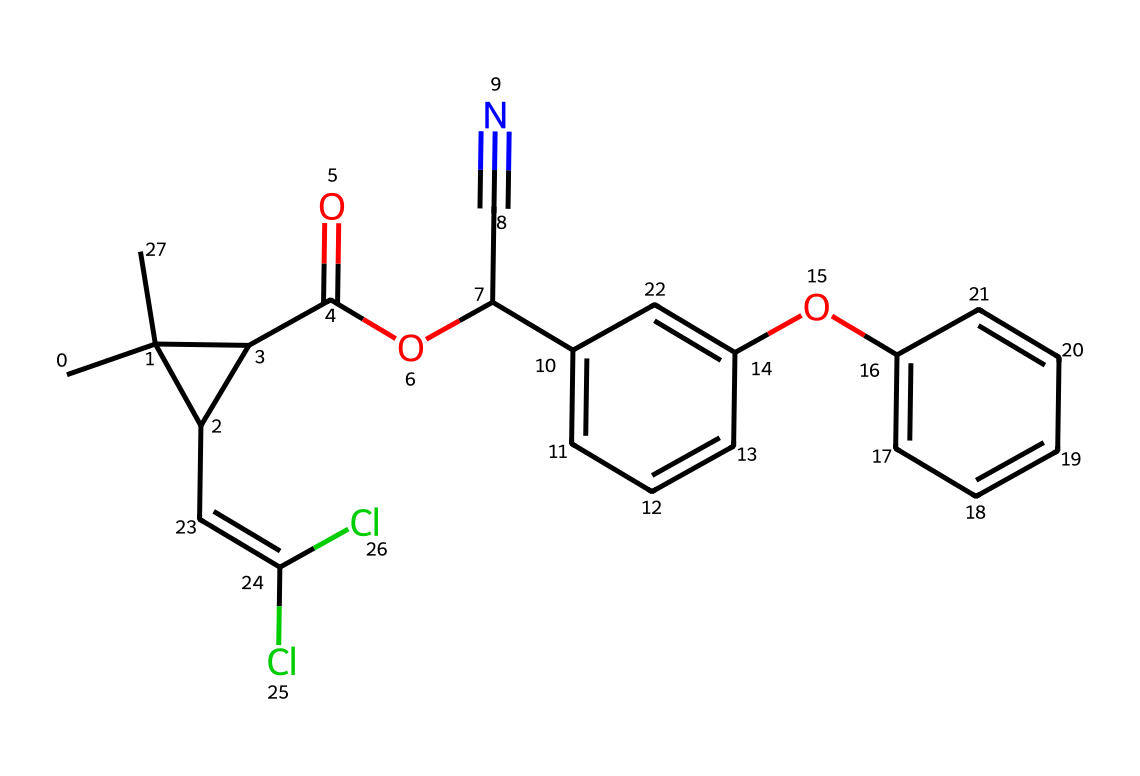How many carbon atoms are in the molecule? Count the carbon atoms in the provided SMILES structure. By analyzing the structure, we identify that there are a total of 16 carbon atoms present in the molecule.
Answer: 16 What functional group is present in this chemical? Examine the SMILES for specific groups typical in the structure of organic compounds. Here, the presence of a carbonyl group (C=O) indicates that it contains an ester functional group.
Answer: ester What is the molecular weight of permethrin? The molecular weight can be calculated based on the number of each type of atom in the structure. Here we find the total molecular weight is approximately 255.25 g/mol.
Answer: 255.25 How many chlorine atoms are in this structure? Inspect the SMILES to find chlorine atoms. There are two instances of 'Cl' in the structure, indicating there are two chlorine atoms present in the molecule.
Answer: 2 What type of pesticide is permethrin classified as? Consider the mode of action or target for permethrin. Since it primarilytargets insects by disrupting their nervous system, it is classified as a pyrethroid insecticide.
Answer: pyrethroid What is the role of the cyano group in this chemical? Analyze the significance of the cyano group (C#N) in relation to the insecticidal properties. The cyano group enhances the bioactivity by promoting penetration through membranes, increasing efficacy against pests.
Answer: enhances bioactivity 